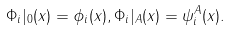<formula> <loc_0><loc_0><loc_500><loc_500>\Phi _ { i } | _ { 0 } ( x ) = \phi _ { i } ( x ) , \Phi _ { i } | _ { A } ( x ) = \psi _ { i } ^ { A } ( x ) .</formula> 